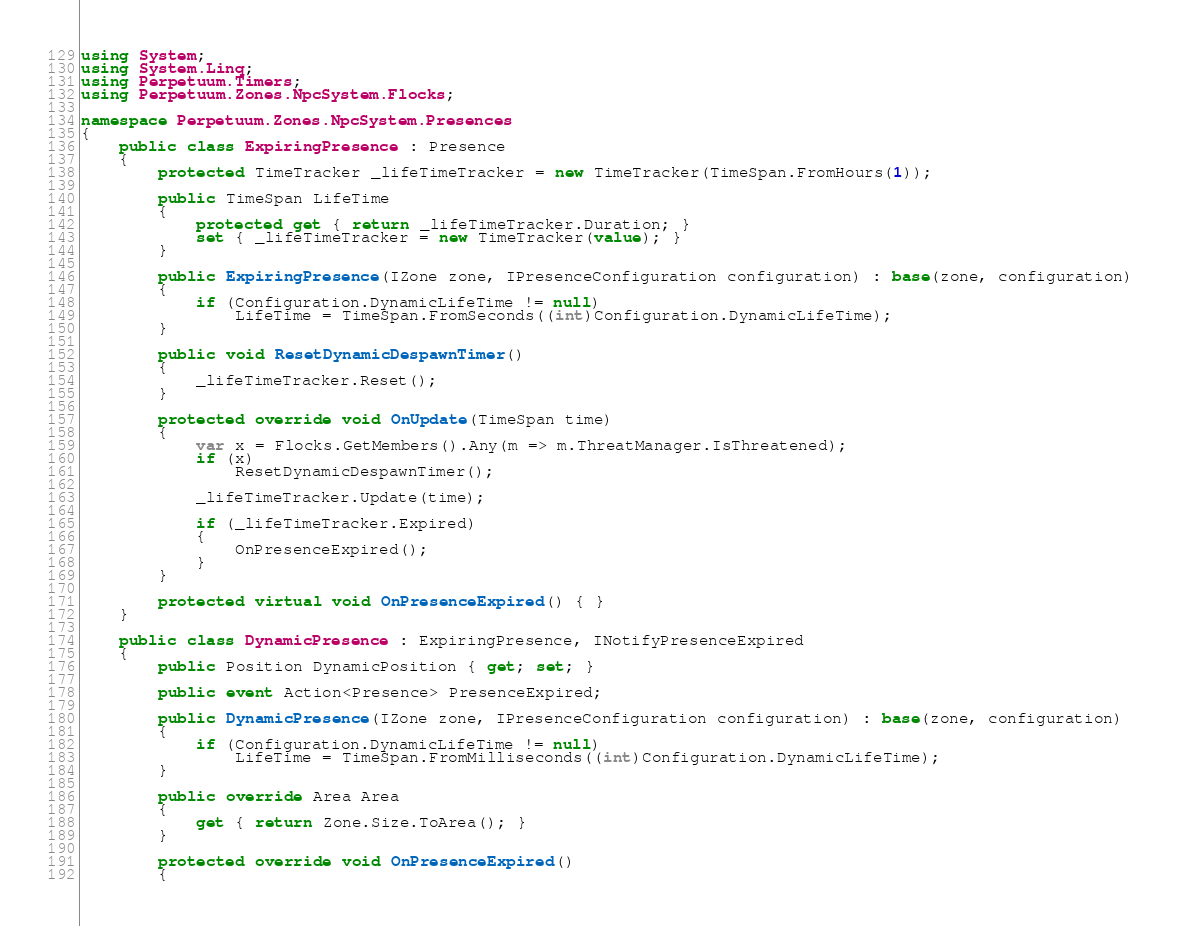Convert code to text. <code><loc_0><loc_0><loc_500><loc_500><_C#_>using System;
using System.Linq;
using Perpetuum.Timers;
using Perpetuum.Zones.NpcSystem.Flocks;

namespace Perpetuum.Zones.NpcSystem.Presences
{
    public class ExpiringPresence : Presence
    {
        protected TimeTracker _lifeTimeTracker = new TimeTracker(TimeSpan.FromHours(1));

        public TimeSpan LifeTime
        {
            protected get { return _lifeTimeTracker.Duration; }
            set { _lifeTimeTracker = new TimeTracker(value); }
        }

        public ExpiringPresence(IZone zone, IPresenceConfiguration configuration) : base(zone, configuration)
        {
            if (Configuration.DynamicLifeTime != null)
                LifeTime = TimeSpan.FromSeconds((int)Configuration.DynamicLifeTime);
        }

        public void ResetDynamicDespawnTimer()
        {
            _lifeTimeTracker.Reset();
        }

        protected override void OnUpdate(TimeSpan time)
        {
            var x = Flocks.GetMembers().Any(m => m.ThreatManager.IsThreatened);
            if (x)
                ResetDynamicDespawnTimer();

            _lifeTimeTracker.Update(time);

            if (_lifeTimeTracker.Expired)
            {
                OnPresenceExpired();
            }
        }

        protected virtual void OnPresenceExpired() { }
    }

    public class DynamicPresence : ExpiringPresence, INotifyPresenceExpired
    {
        public Position DynamicPosition { get; set; }

        public event Action<Presence> PresenceExpired;

        public DynamicPresence(IZone zone, IPresenceConfiguration configuration) : base(zone, configuration)
        {
            if (Configuration.DynamicLifeTime != null)
                LifeTime = TimeSpan.FromMilliseconds((int)Configuration.DynamicLifeTime);
        }

        public override Area Area
        {
            get { return Zone.Size.ToArea(); }
        }

        protected override void OnPresenceExpired()
        {</code> 